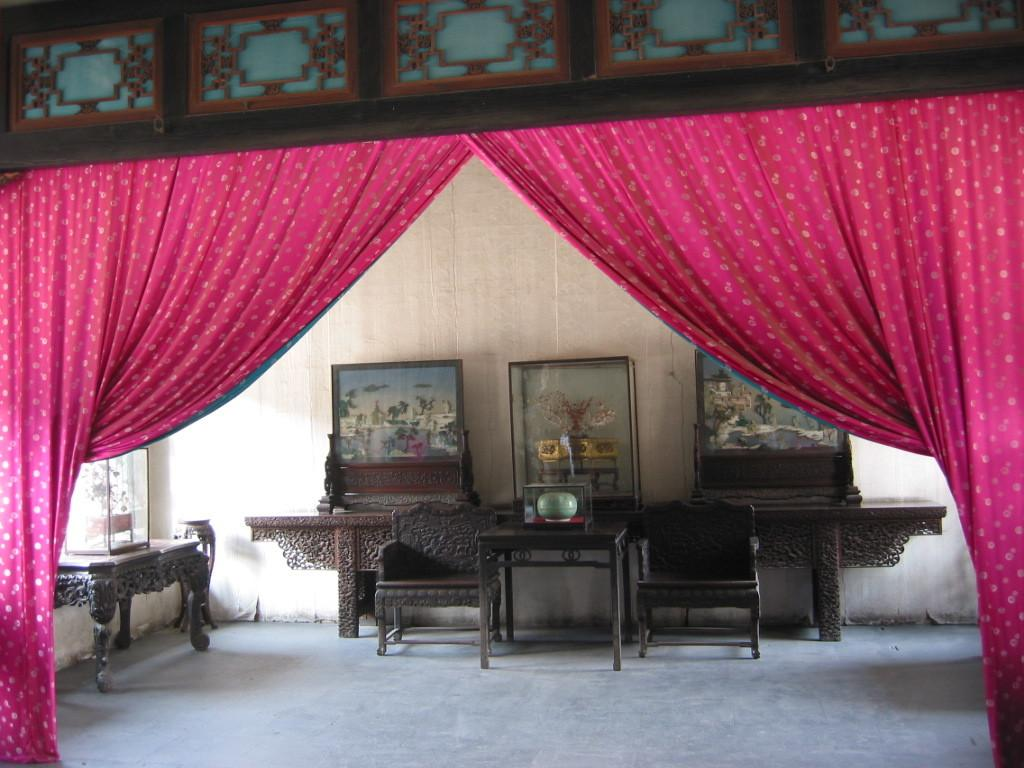What type of furniture can be seen in the image? There are chairs in the image. What are the tables in the image used for? The tables have objects on them, suggesting they are used for placing or displaying items. What color are the curtains in the image? The curtains are red in color. What is the background of the image made of? There is a wall in the image, which serves as the background. Can you describe any other objects present in the image? Yes, there are other objects present in the image, but we cannot determine their specific nature or function from the given facts. Is there a slope visible in the image? No, there is no slope present in the image. How do the chairs act in the image? The chairs do not act in the image; they are inanimate objects used for sitting. 